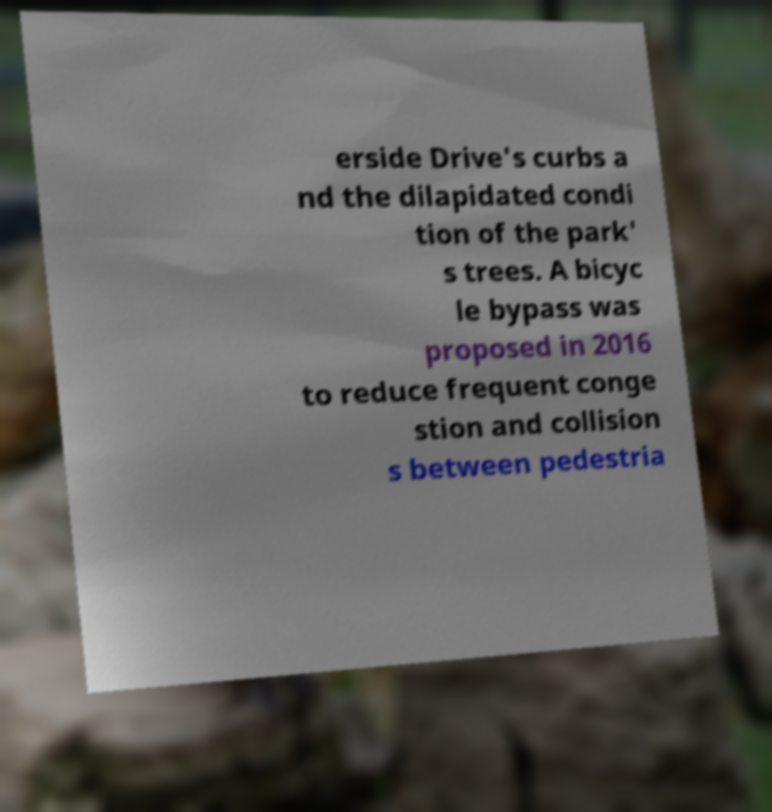There's text embedded in this image that I need extracted. Can you transcribe it verbatim? erside Drive's curbs a nd the dilapidated condi tion of the park' s trees. A bicyc le bypass was proposed in 2016 to reduce frequent conge stion and collision s between pedestria 